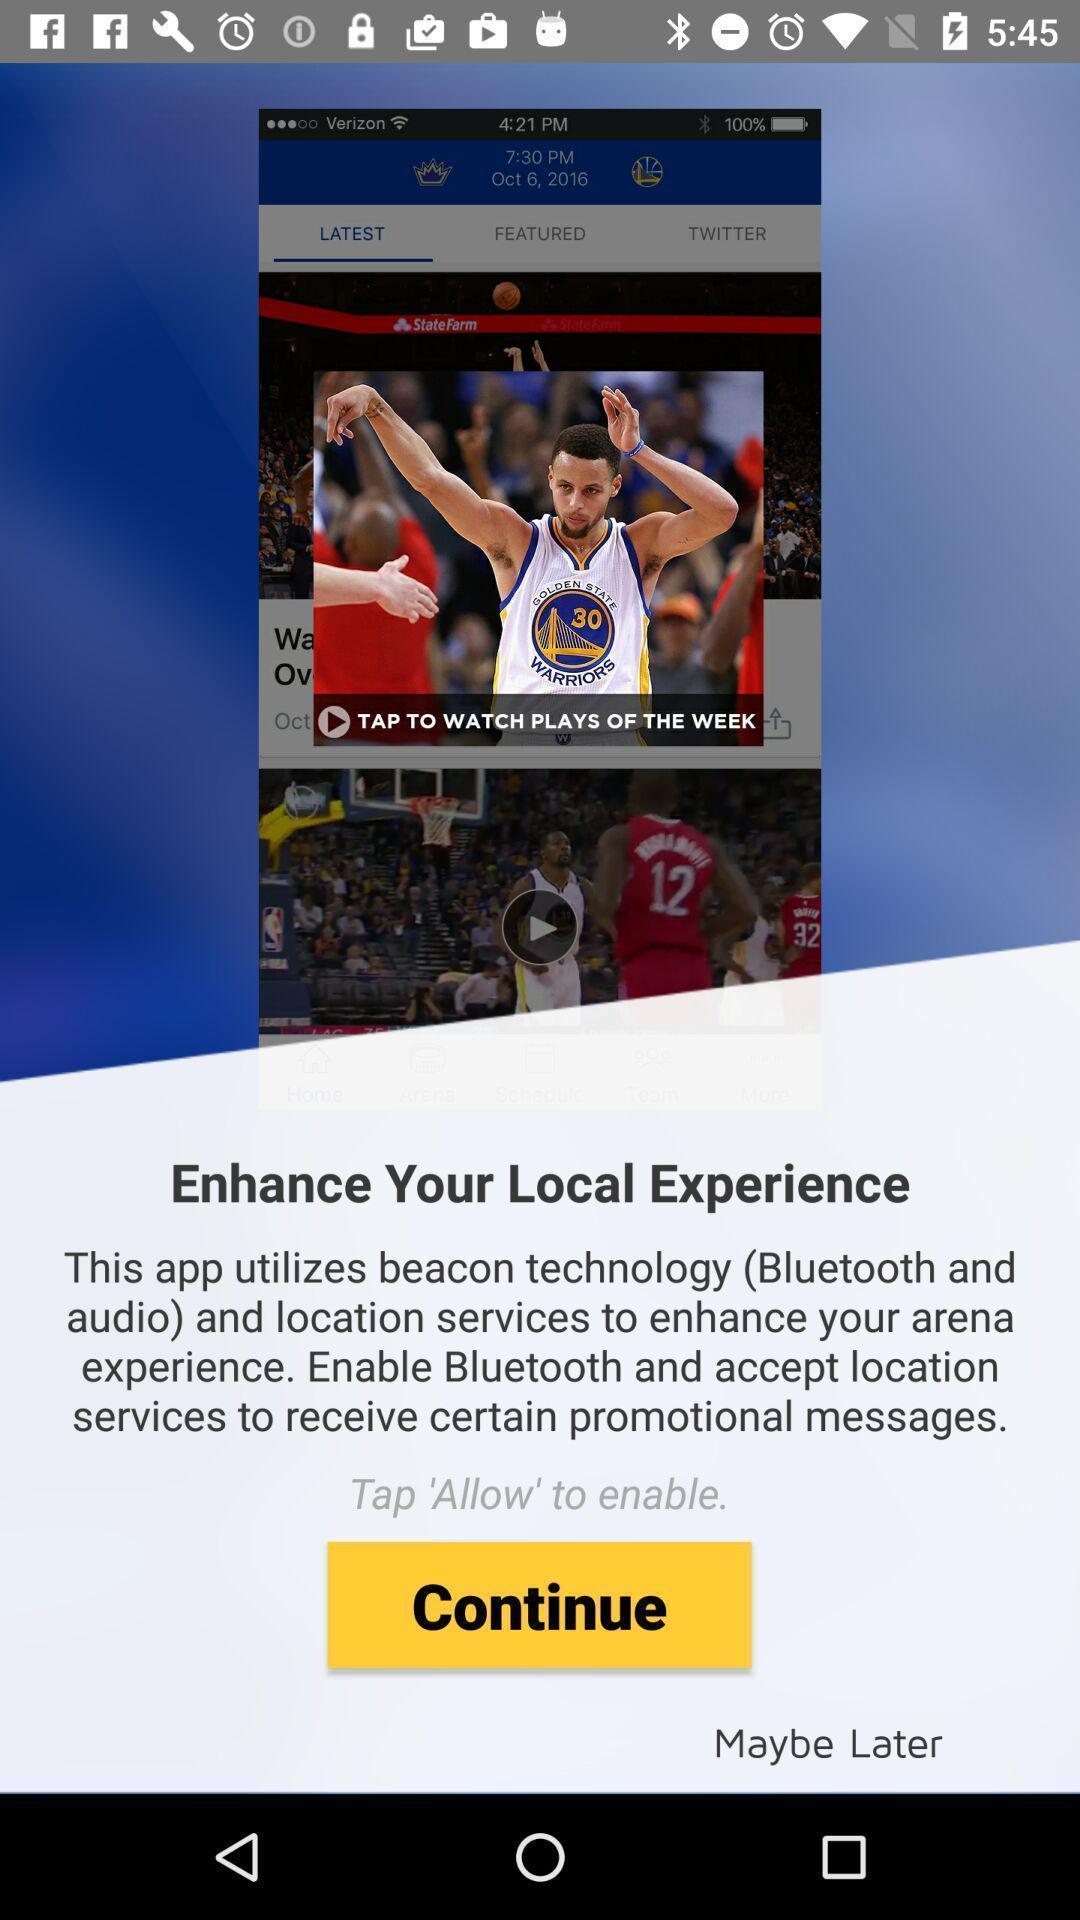Tell me what you see in this picture. Welcome page a sports app. 